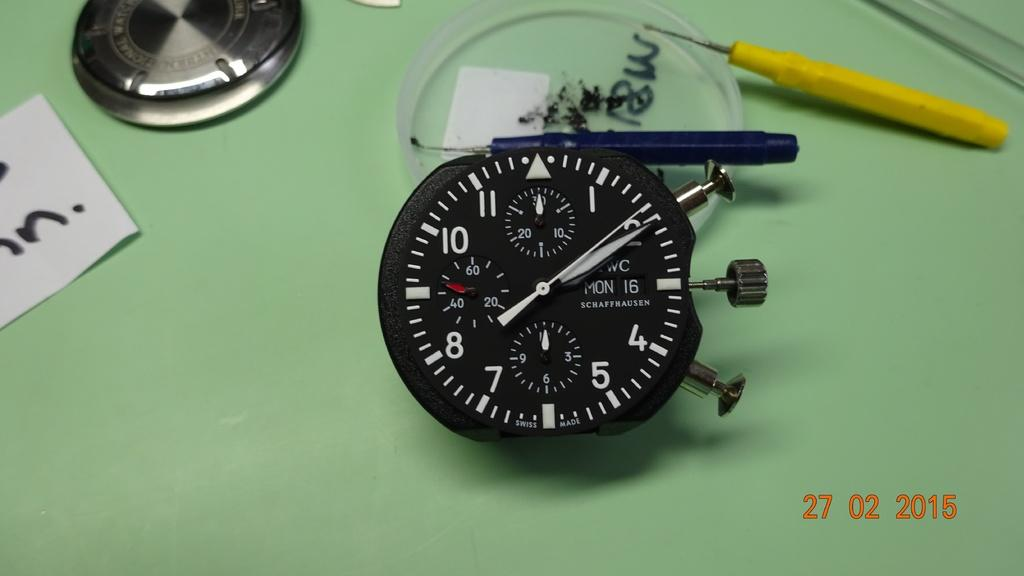Provide a one-sentence caption for the provided image. A Swiss made timer has Mon the 16th on the face. 